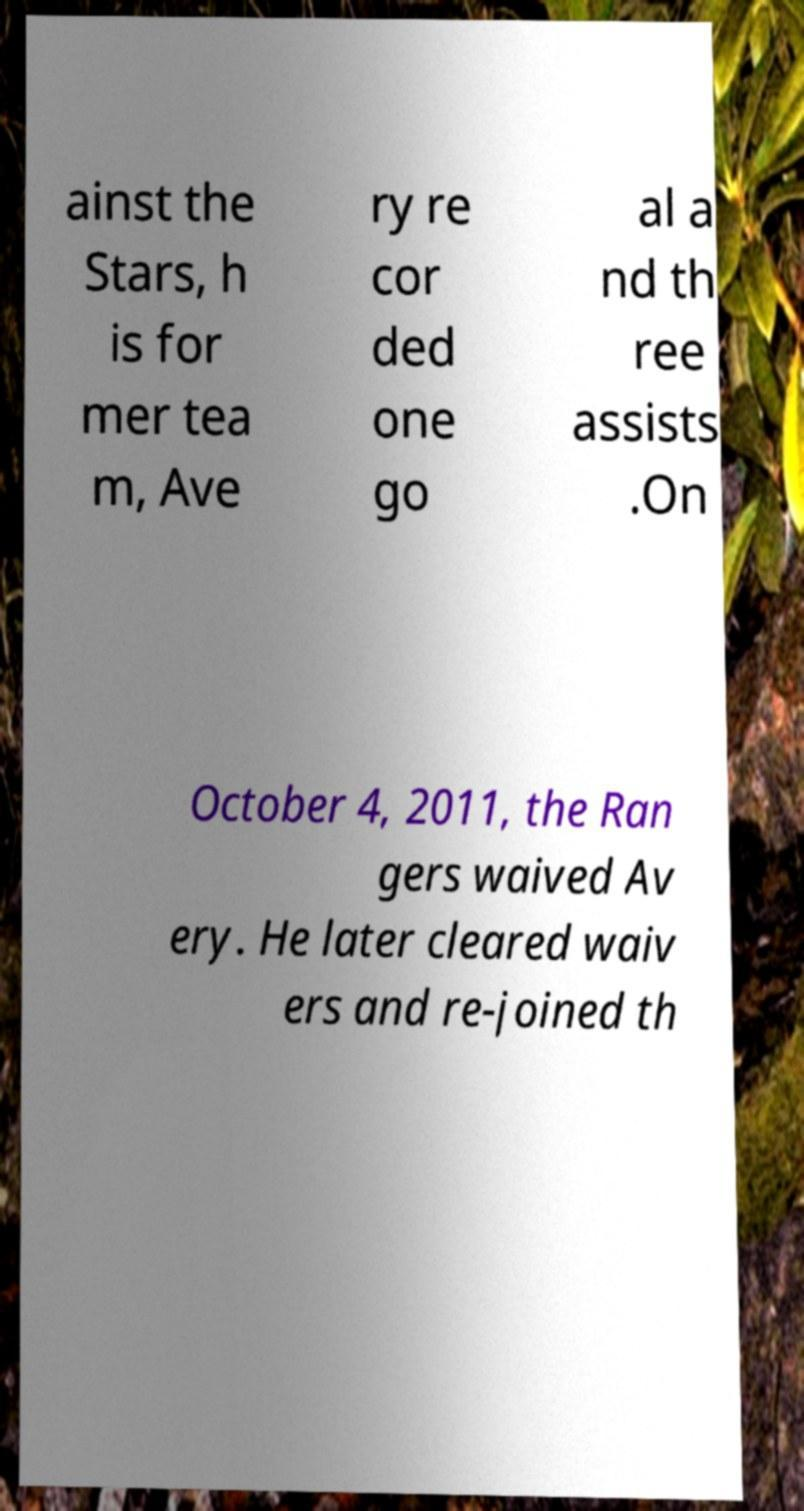Can you read and provide the text displayed in the image?This photo seems to have some interesting text. Can you extract and type it out for me? ainst the Stars, h is for mer tea m, Ave ry re cor ded one go al a nd th ree assists .On October 4, 2011, the Ran gers waived Av ery. He later cleared waiv ers and re-joined th 